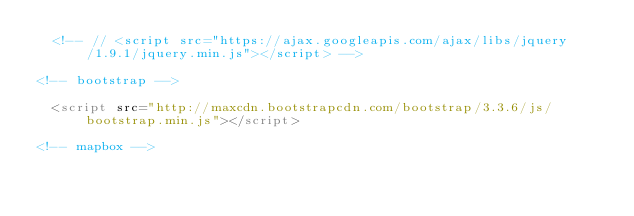Convert code to text. <code><loc_0><loc_0><loc_500><loc_500><_HTML_>  <!-- // <script src="https://ajax.googleapis.com/ajax/libs/jquery/1.9.1/jquery.min.js"></script> -->

<!-- bootstrap -->

  <script src="http://maxcdn.bootstrapcdn.com/bootstrap/3.3.6/js/bootstrap.min.js"></script>

<!-- mapbox --></code> 